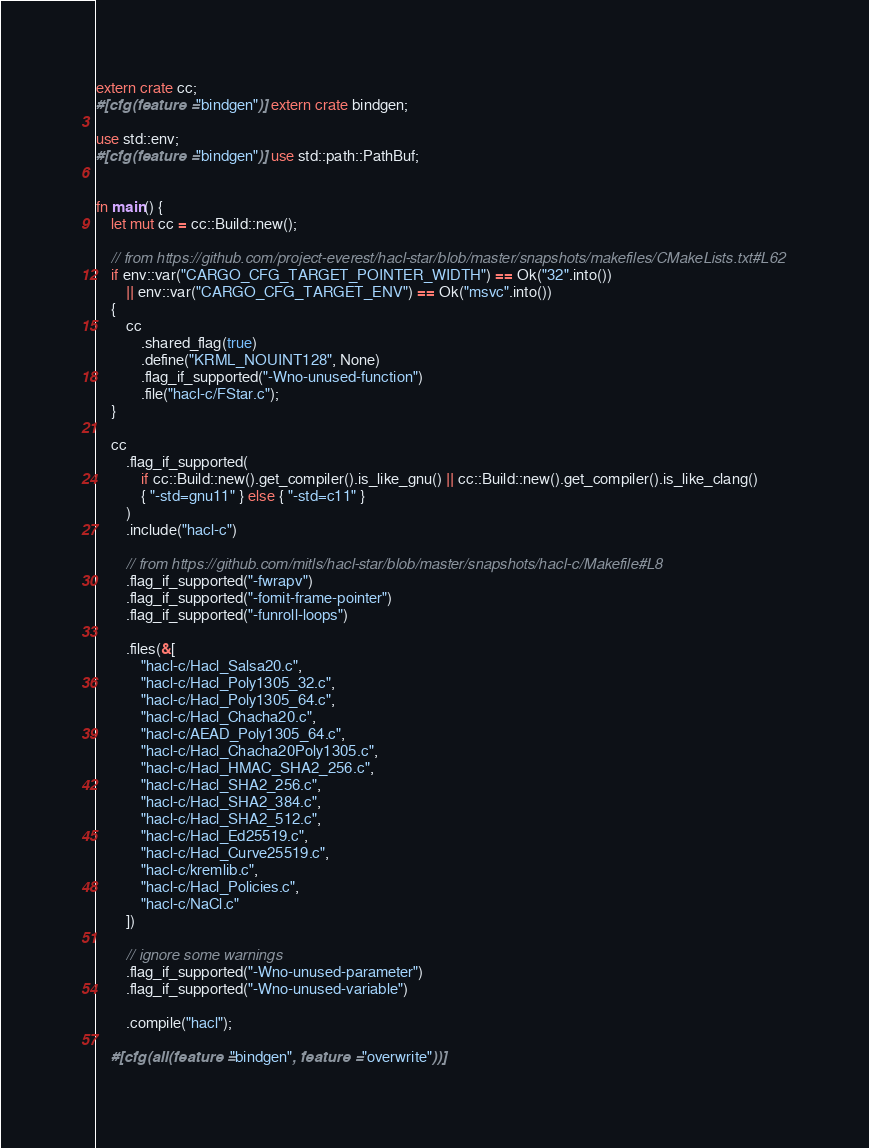<code> <loc_0><loc_0><loc_500><loc_500><_Rust_>extern crate cc;
#[cfg(feature = "bindgen")] extern crate bindgen;

use std::env;
#[cfg(feature = "bindgen")] use std::path::PathBuf;


fn main() {
    let mut cc = cc::Build::new();

    // from https://github.com/project-everest/hacl-star/blob/master/snapshots/makefiles/CMakeLists.txt#L62
    if env::var("CARGO_CFG_TARGET_POINTER_WIDTH") == Ok("32".into())
        || env::var("CARGO_CFG_TARGET_ENV") == Ok("msvc".into())
    {
        cc
            .shared_flag(true)
            .define("KRML_NOUINT128", None)
            .flag_if_supported("-Wno-unused-function")
            .file("hacl-c/FStar.c");
    }

    cc
        .flag_if_supported(
            if cc::Build::new().get_compiler().is_like_gnu() || cc::Build::new().get_compiler().is_like_clang()
            { "-std=gnu11" } else { "-std=c11" }
        )
        .include("hacl-c")

        // from https://github.com/mitls/hacl-star/blob/master/snapshots/hacl-c/Makefile#L8
        .flag_if_supported("-fwrapv")
        .flag_if_supported("-fomit-frame-pointer")
        .flag_if_supported("-funroll-loops")

        .files(&[
            "hacl-c/Hacl_Salsa20.c",
            "hacl-c/Hacl_Poly1305_32.c",
            "hacl-c/Hacl_Poly1305_64.c",
            "hacl-c/Hacl_Chacha20.c",
            "hacl-c/AEAD_Poly1305_64.c",
            "hacl-c/Hacl_Chacha20Poly1305.c",
            "hacl-c/Hacl_HMAC_SHA2_256.c",
            "hacl-c/Hacl_SHA2_256.c",
            "hacl-c/Hacl_SHA2_384.c",
            "hacl-c/Hacl_SHA2_512.c",
            "hacl-c/Hacl_Ed25519.c",
            "hacl-c/Hacl_Curve25519.c",
            "hacl-c/kremlib.c",
            "hacl-c/Hacl_Policies.c",
            "hacl-c/NaCl.c"
        ])

        // ignore some warnings
        .flag_if_supported("-Wno-unused-parameter")
        .flag_if_supported("-Wno-unused-variable")

        .compile("hacl");

    #[cfg(all(feature = "bindgen", feature = "overwrite"))]</code> 